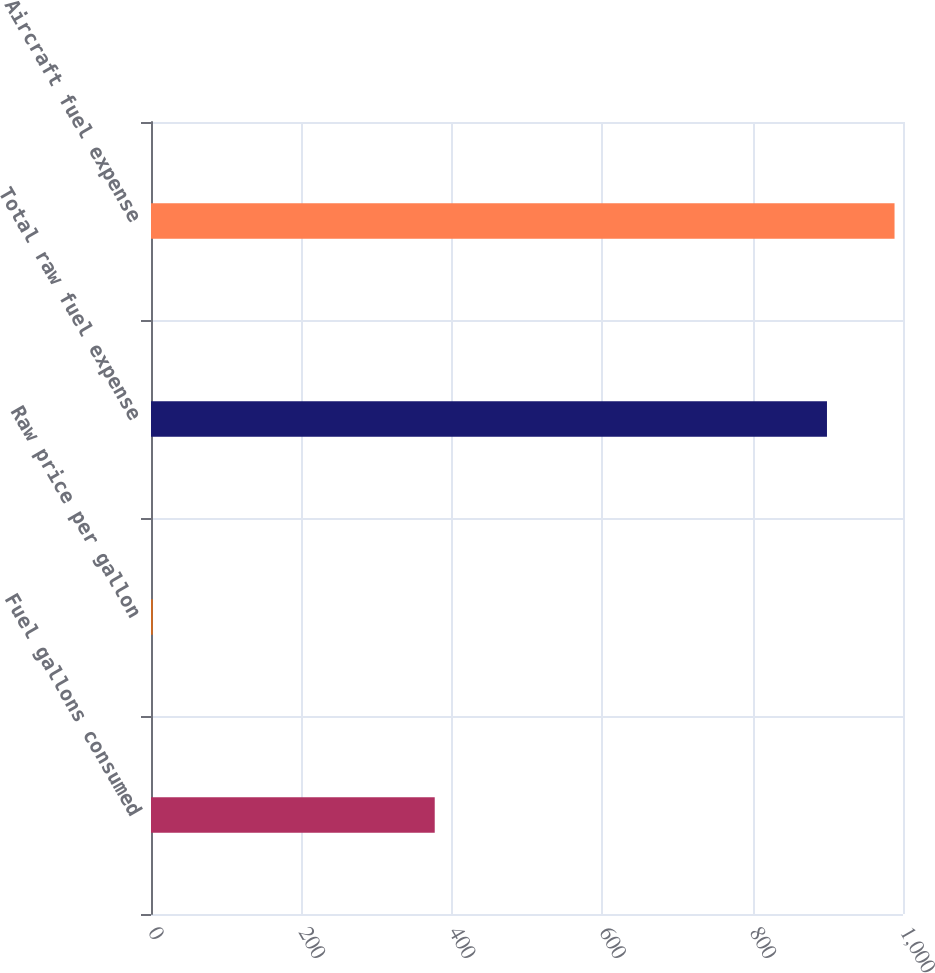<chart> <loc_0><loc_0><loc_500><loc_500><bar_chart><fcel>Fuel gallons consumed<fcel>Raw price per gallon<fcel>Total raw fuel expense<fcel>Aircraft fuel expense<nl><fcel>377.3<fcel>2.38<fcel>898.9<fcel>988.75<nl></chart> 